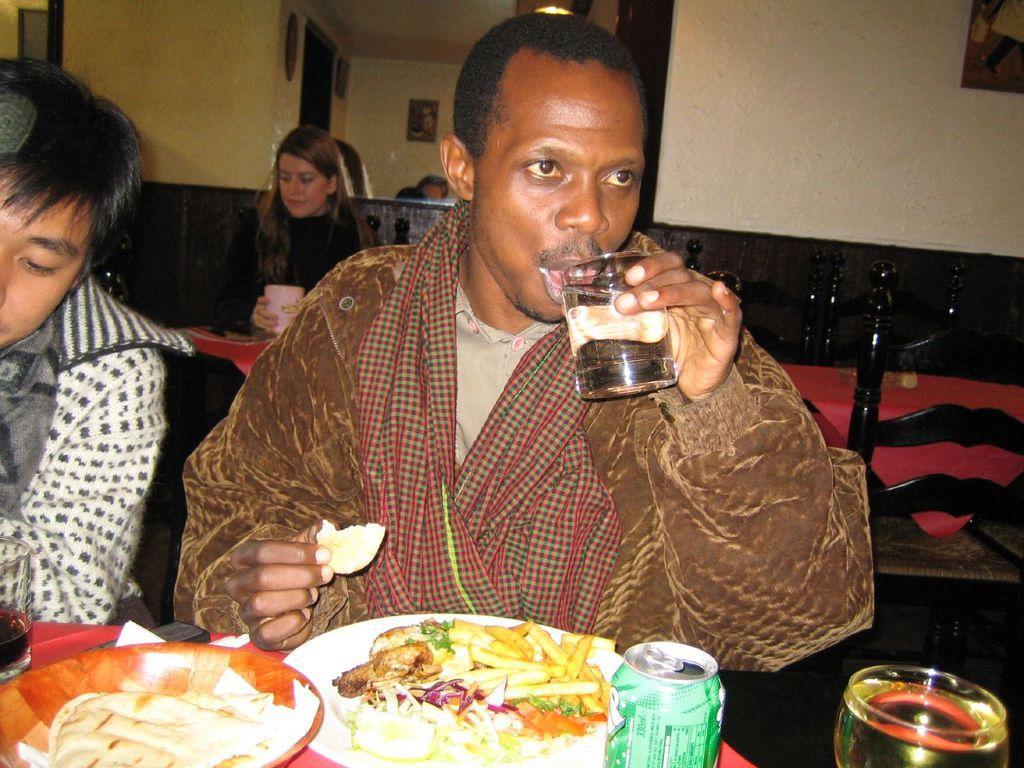In one or two sentences, can you explain what this image depicts? In this image there are three persons sitting on the cars , there are tables, chairs, on one table there are glasses, food items on the plates , tin ,a person holding a glass , and in the background there are frames attached to the wall. 